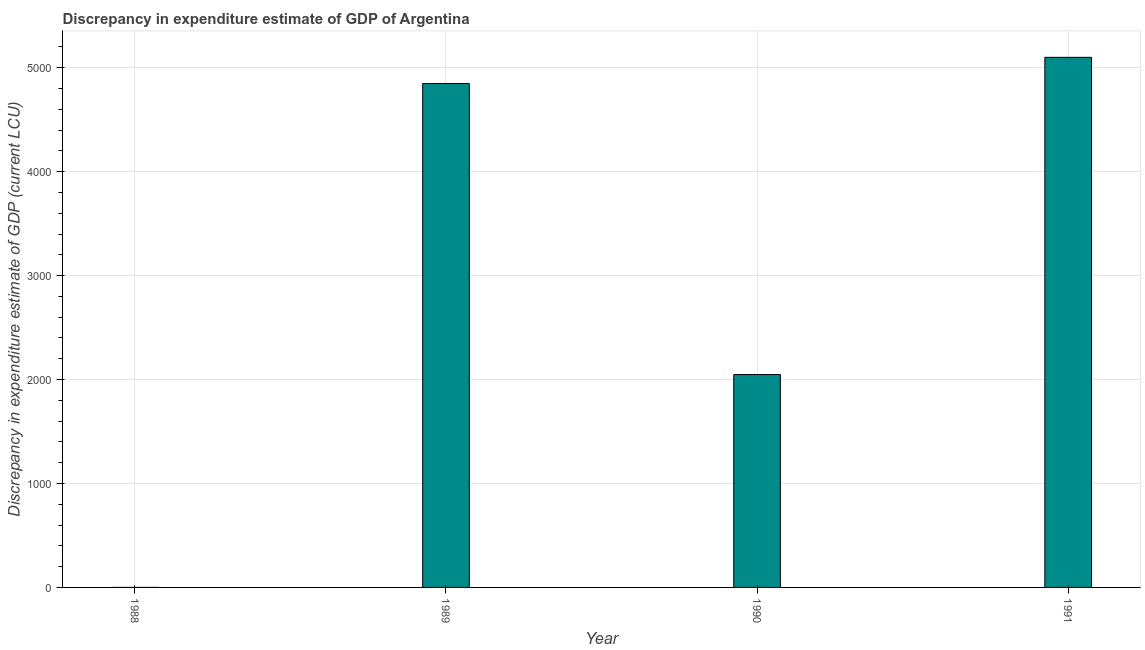Does the graph contain any zero values?
Make the answer very short. Yes. Does the graph contain grids?
Give a very brief answer. Yes. What is the title of the graph?
Your response must be concise. Discrepancy in expenditure estimate of GDP of Argentina. What is the label or title of the X-axis?
Provide a succinct answer. Year. What is the label or title of the Y-axis?
Your response must be concise. Discrepancy in expenditure estimate of GDP (current LCU). What is the discrepancy in expenditure estimate of gdp in 1991?
Ensure brevity in your answer.  5100. Across all years, what is the maximum discrepancy in expenditure estimate of gdp?
Your answer should be compact. 5100. Across all years, what is the minimum discrepancy in expenditure estimate of gdp?
Give a very brief answer. 0. What is the sum of the discrepancy in expenditure estimate of gdp?
Provide a succinct answer. 1.20e+04. What is the difference between the discrepancy in expenditure estimate of gdp in 1989 and 1991?
Keep it short and to the point. -252. What is the average discrepancy in expenditure estimate of gdp per year?
Provide a succinct answer. 2999. What is the median discrepancy in expenditure estimate of gdp?
Your answer should be very brief. 3448. What is the ratio of the discrepancy in expenditure estimate of gdp in 1989 to that in 1990?
Your answer should be very brief. 2.37. Is the difference between the discrepancy in expenditure estimate of gdp in 1989 and 1991 greater than the difference between any two years?
Provide a short and direct response. No. What is the difference between the highest and the second highest discrepancy in expenditure estimate of gdp?
Provide a succinct answer. 252. What is the difference between the highest and the lowest discrepancy in expenditure estimate of gdp?
Make the answer very short. 5100. How many years are there in the graph?
Provide a short and direct response. 4. What is the difference between two consecutive major ticks on the Y-axis?
Your response must be concise. 1000. Are the values on the major ticks of Y-axis written in scientific E-notation?
Your answer should be compact. No. What is the Discrepancy in expenditure estimate of GDP (current LCU) of 1989?
Your response must be concise. 4848. What is the Discrepancy in expenditure estimate of GDP (current LCU) of 1990?
Offer a very short reply. 2048. What is the Discrepancy in expenditure estimate of GDP (current LCU) of 1991?
Your answer should be very brief. 5100. What is the difference between the Discrepancy in expenditure estimate of GDP (current LCU) in 1989 and 1990?
Your answer should be compact. 2800. What is the difference between the Discrepancy in expenditure estimate of GDP (current LCU) in 1989 and 1991?
Provide a short and direct response. -252. What is the difference between the Discrepancy in expenditure estimate of GDP (current LCU) in 1990 and 1991?
Offer a very short reply. -3052. What is the ratio of the Discrepancy in expenditure estimate of GDP (current LCU) in 1989 to that in 1990?
Your response must be concise. 2.37. What is the ratio of the Discrepancy in expenditure estimate of GDP (current LCU) in 1989 to that in 1991?
Provide a succinct answer. 0.95. What is the ratio of the Discrepancy in expenditure estimate of GDP (current LCU) in 1990 to that in 1991?
Provide a short and direct response. 0.4. 